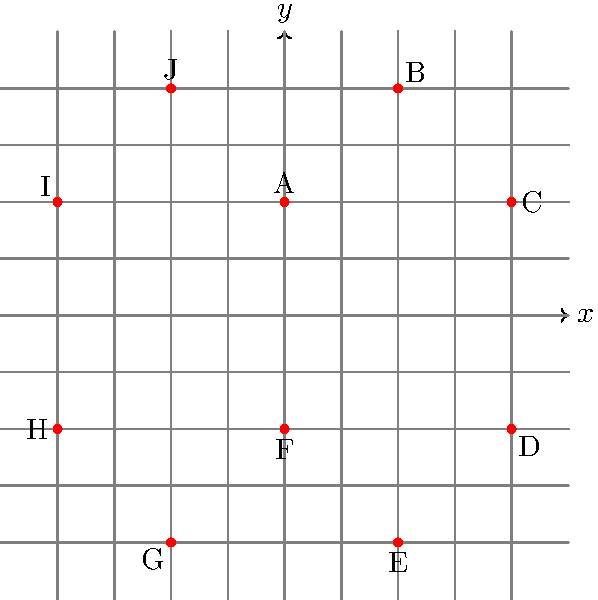As a retired art critic, you're tasked with analyzing a stylized representation of King's College Chapel on a coordinate plane. The diagram shows 10 points (A to J) that, when connected, form a simplified outline of the chapel's iconic silhouette. If the coordinates of point A are $(0,4)$, what are the coordinates of point E? Let's approach this step-by-step:

1) First, we observe that the figure is symmetrical about the y-axis.

2) Point A is given as $(0,4)$, which is 4 units up from the origin.

3) Moving clockwise, we can see that each subsequent point follows a pattern:
   - B is 4 units right and 4 units up from A
   - C is 4 units right and 4 units down from B
   - D is 8 units down from C
   - E is 4 units left and 4 units down from D

4) Let's count the steps to get to E:
   - From A $(0,4)$ to B: $(4,8)$
   - From B to C: $(8,4)$
   - From C to D: $(8,-4)$
   - From D to E: $(4,-8)$

5) Therefore, the coordinates of point E are $(4,-8)$.

This stylized representation captures the essence of King's College Chapel's distinctive profile, with its central spire (point B) and the sloping rooflines of the side chapels (lines BC and BA).
Answer: $(4,-8)$ 